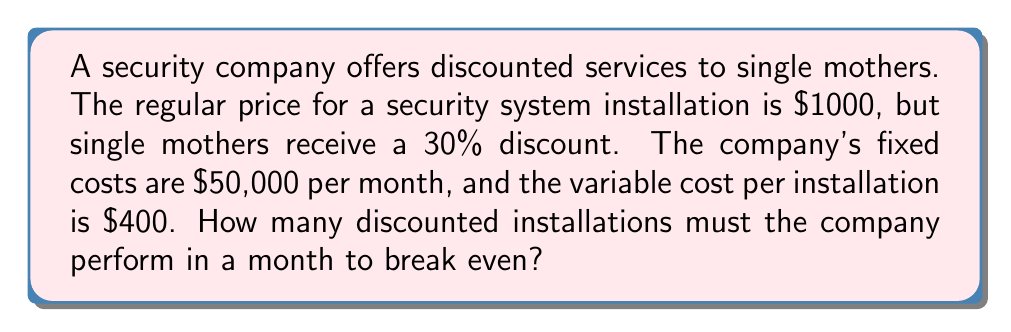Show me your answer to this math problem. Let's approach this step-by-step:

1) First, let's calculate the discounted price for single mothers:
   Regular price = $1000
   Discount = 30% = 0.3
   Discounted price = $1000 * (1 - 0.3) = $700

2) Now, let's define our variables:
   Let $x$ be the number of installations needed to break even
   Fixed costs (FC) = $50,000
   Variable cost per installation (VC) = $400
   Price per discounted installation (P) = $700

3) The break-even point occurs when Total Revenue equals Total Costs:
   $$ TR = TC $$
   $$ Px = FC + VCx $$

4) Substituting our values:
   $$ 700x = 50,000 + 400x $$

5) Solve for $x$:
   $$ 700x - 400x = 50,000 $$
   $$ 300x = 50,000 $$
   $$ x = \frac{50,000}{300} = 166.67 $$

6) Since we can't perform partial installations, we round up to the nearest whole number.
Answer: 167 installations 